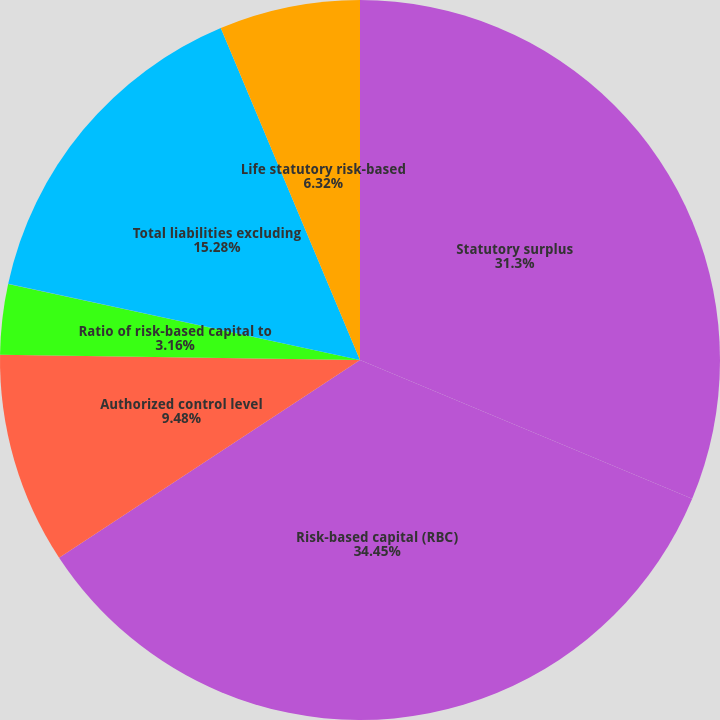Convert chart to OTSL. <chart><loc_0><loc_0><loc_500><loc_500><pie_chart><fcel>Statutory surplus<fcel>Risk-based capital (RBC)<fcel>Authorized control level<fcel>Ratio of risk-based capital to<fcel>Written premium to surplus<fcel>Total liabilities excluding<fcel>Life statutory risk-based<nl><fcel>31.3%<fcel>34.45%<fcel>9.48%<fcel>3.16%<fcel>0.01%<fcel>15.28%<fcel>6.32%<nl></chart> 